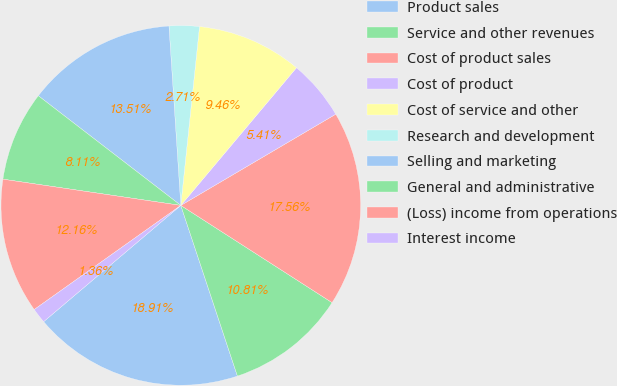Convert chart to OTSL. <chart><loc_0><loc_0><loc_500><loc_500><pie_chart><fcel>Product sales<fcel>Service and other revenues<fcel>Cost of product sales<fcel>Cost of product<fcel>Cost of service and other<fcel>Research and development<fcel>Selling and marketing<fcel>General and administrative<fcel>(Loss) income from operations<fcel>Interest income<nl><fcel>18.91%<fcel>10.81%<fcel>17.56%<fcel>5.41%<fcel>9.46%<fcel>2.71%<fcel>13.51%<fcel>8.11%<fcel>12.16%<fcel>1.36%<nl></chart> 